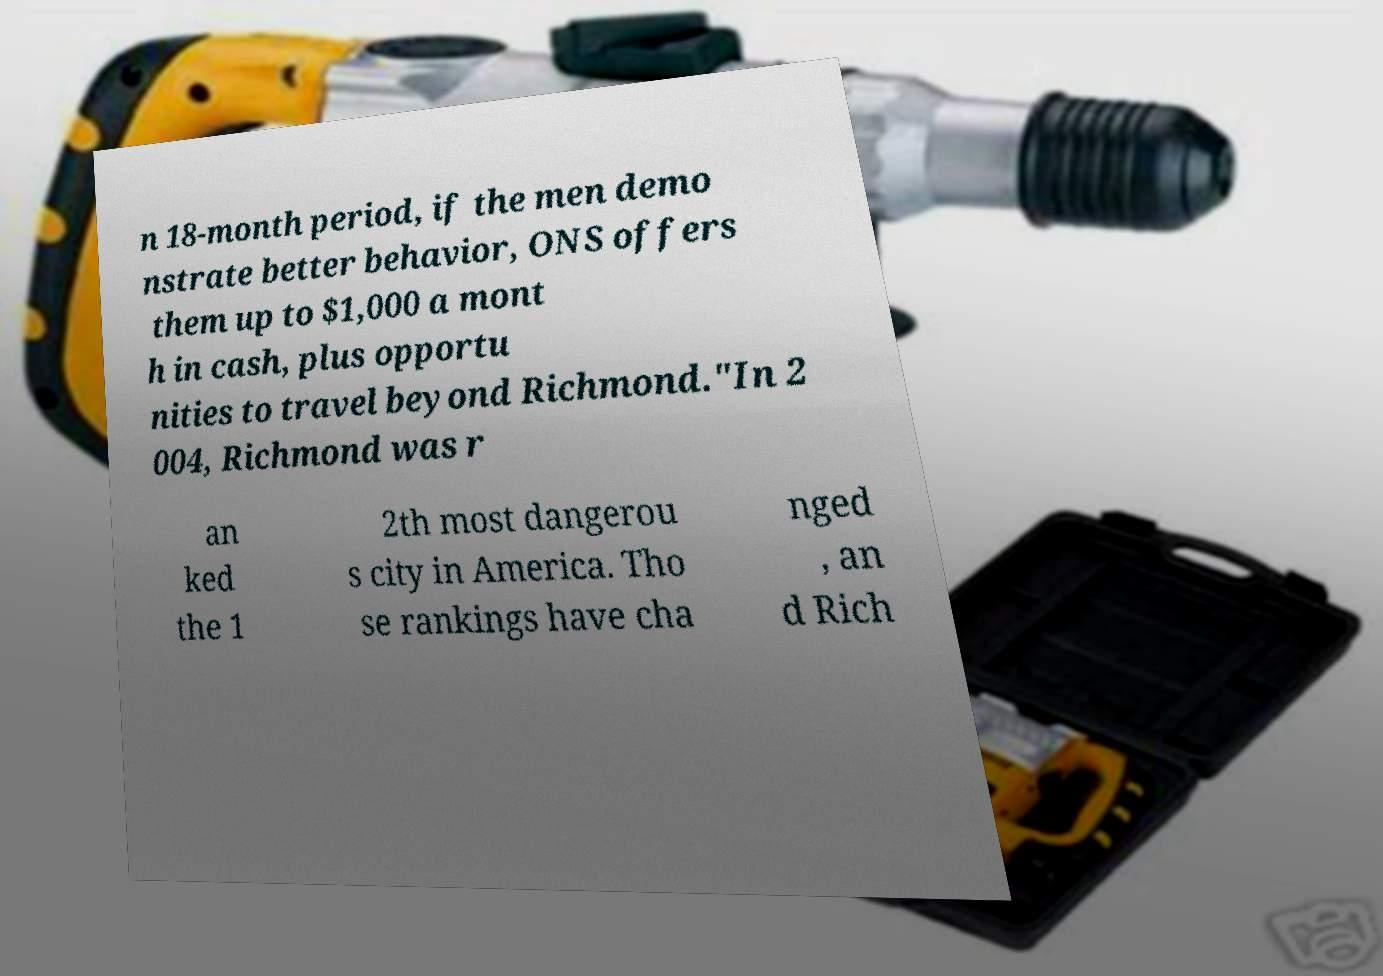What messages or text are displayed in this image? I need them in a readable, typed format. n 18-month period, if the men demo nstrate better behavior, ONS offers them up to $1,000 a mont h in cash, plus opportu nities to travel beyond Richmond."In 2 004, Richmond was r an ked the 1 2th most dangerou s city in America. Tho se rankings have cha nged , an d Rich 